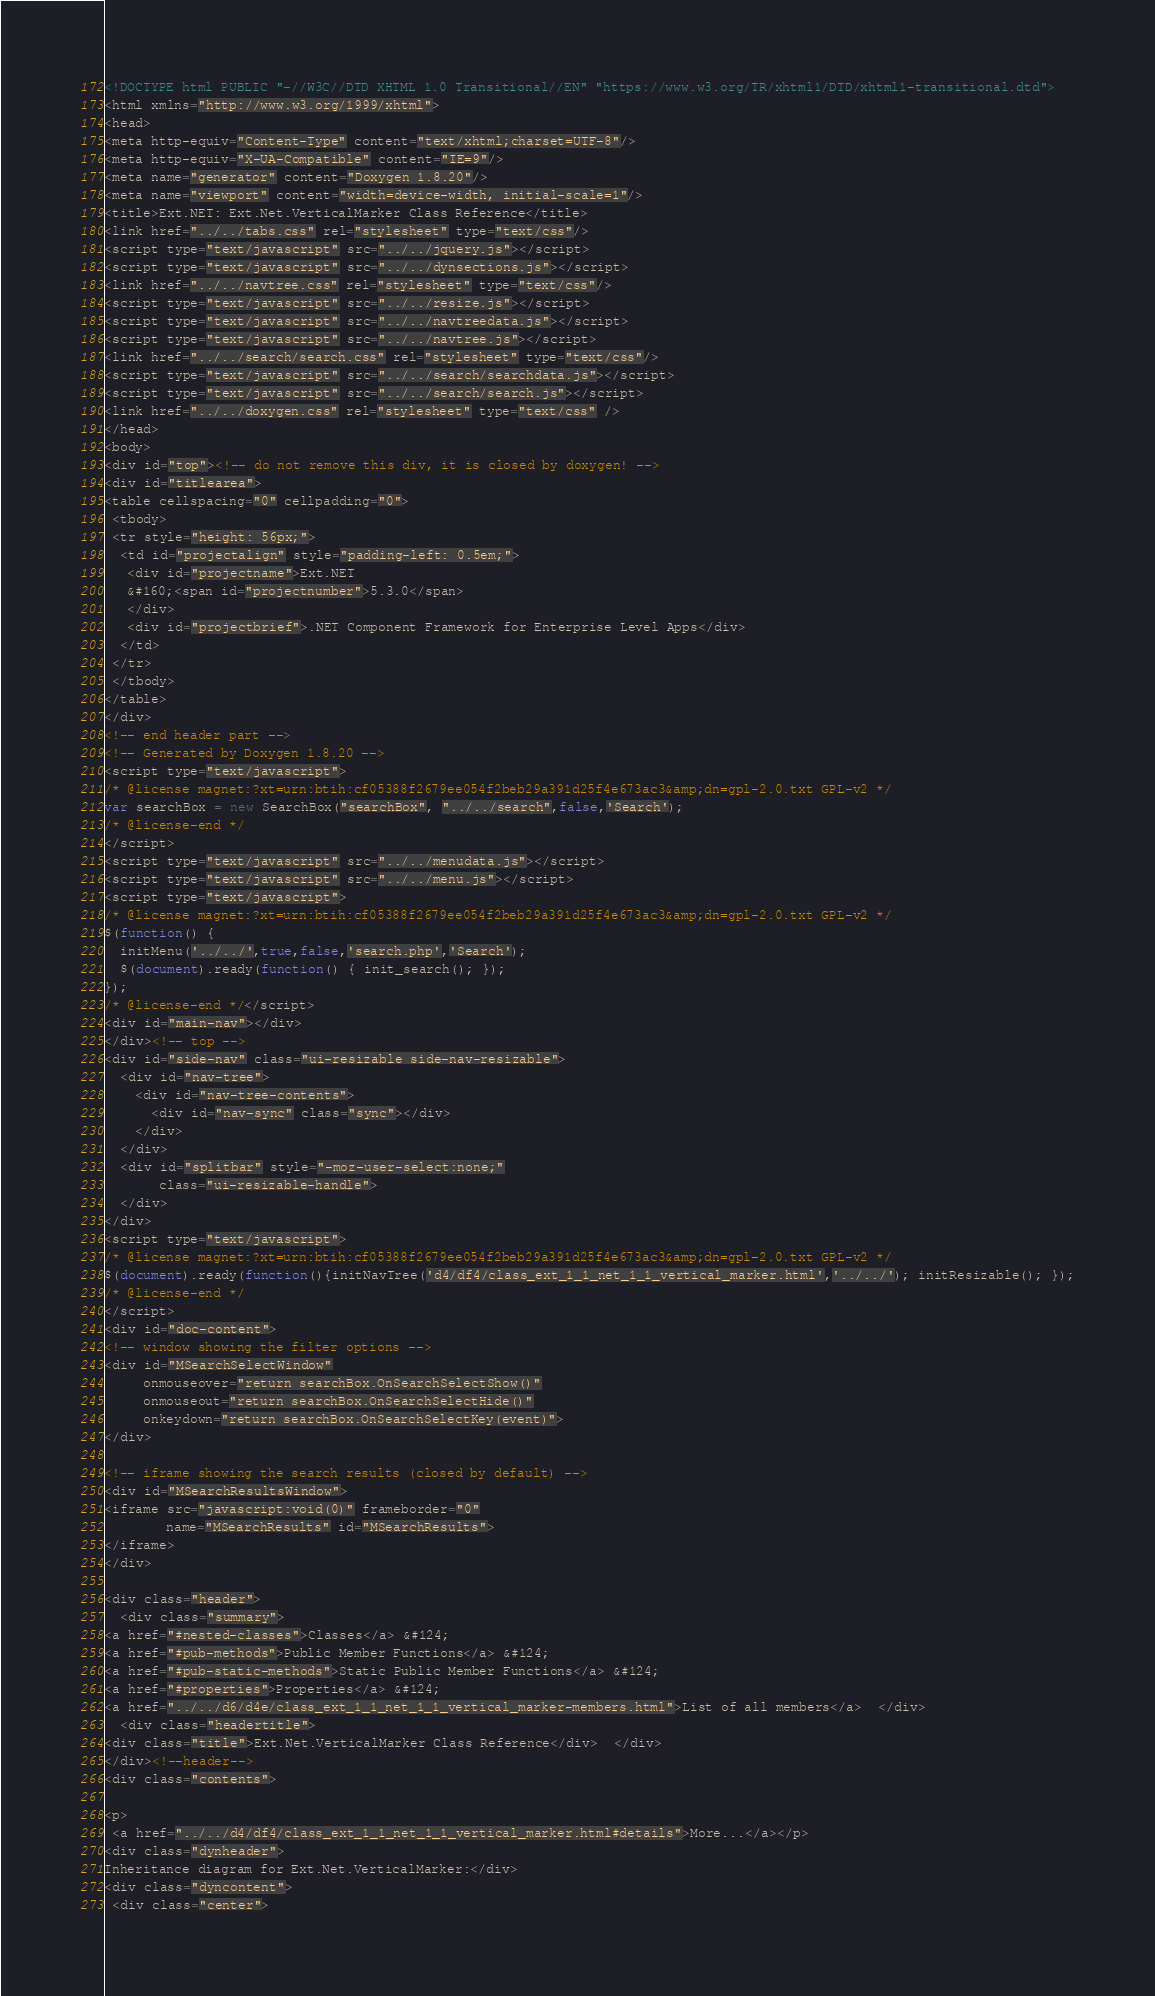<code> <loc_0><loc_0><loc_500><loc_500><_HTML_><!DOCTYPE html PUBLIC "-//W3C//DTD XHTML 1.0 Transitional//EN" "https://www.w3.org/TR/xhtml1/DTD/xhtml1-transitional.dtd">
<html xmlns="http://www.w3.org/1999/xhtml">
<head>
<meta http-equiv="Content-Type" content="text/xhtml;charset=UTF-8"/>
<meta http-equiv="X-UA-Compatible" content="IE=9"/>
<meta name="generator" content="Doxygen 1.8.20"/>
<meta name="viewport" content="width=device-width, initial-scale=1"/>
<title>Ext.NET: Ext.Net.VerticalMarker Class Reference</title>
<link href="../../tabs.css" rel="stylesheet" type="text/css"/>
<script type="text/javascript" src="../../jquery.js"></script>
<script type="text/javascript" src="../../dynsections.js"></script>
<link href="../../navtree.css" rel="stylesheet" type="text/css"/>
<script type="text/javascript" src="../../resize.js"></script>
<script type="text/javascript" src="../../navtreedata.js"></script>
<script type="text/javascript" src="../../navtree.js"></script>
<link href="../../search/search.css" rel="stylesheet" type="text/css"/>
<script type="text/javascript" src="../../search/searchdata.js"></script>
<script type="text/javascript" src="../../search/search.js"></script>
<link href="../../doxygen.css" rel="stylesheet" type="text/css" />
</head>
<body>
<div id="top"><!-- do not remove this div, it is closed by doxygen! -->
<div id="titlearea">
<table cellspacing="0" cellpadding="0">
 <tbody>
 <tr style="height: 56px;">
  <td id="projectalign" style="padding-left: 0.5em;">
   <div id="projectname">Ext.NET
   &#160;<span id="projectnumber">5.3.0</span>
   </div>
   <div id="projectbrief">.NET Component Framework for Enterprise Level Apps</div>
  </td>
 </tr>
 </tbody>
</table>
</div>
<!-- end header part -->
<!-- Generated by Doxygen 1.8.20 -->
<script type="text/javascript">
/* @license magnet:?xt=urn:btih:cf05388f2679ee054f2beb29a391d25f4e673ac3&amp;dn=gpl-2.0.txt GPL-v2 */
var searchBox = new SearchBox("searchBox", "../../search",false,'Search');
/* @license-end */
</script>
<script type="text/javascript" src="../../menudata.js"></script>
<script type="text/javascript" src="../../menu.js"></script>
<script type="text/javascript">
/* @license magnet:?xt=urn:btih:cf05388f2679ee054f2beb29a391d25f4e673ac3&amp;dn=gpl-2.0.txt GPL-v2 */
$(function() {
  initMenu('../../',true,false,'search.php','Search');
  $(document).ready(function() { init_search(); });
});
/* @license-end */</script>
<div id="main-nav"></div>
</div><!-- top -->
<div id="side-nav" class="ui-resizable side-nav-resizable">
  <div id="nav-tree">
    <div id="nav-tree-contents">
      <div id="nav-sync" class="sync"></div>
    </div>
  </div>
  <div id="splitbar" style="-moz-user-select:none;" 
       class="ui-resizable-handle">
  </div>
</div>
<script type="text/javascript">
/* @license magnet:?xt=urn:btih:cf05388f2679ee054f2beb29a391d25f4e673ac3&amp;dn=gpl-2.0.txt GPL-v2 */
$(document).ready(function(){initNavTree('d4/df4/class_ext_1_1_net_1_1_vertical_marker.html','../../'); initResizable(); });
/* @license-end */
</script>
<div id="doc-content">
<!-- window showing the filter options -->
<div id="MSearchSelectWindow"
     onmouseover="return searchBox.OnSearchSelectShow()"
     onmouseout="return searchBox.OnSearchSelectHide()"
     onkeydown="return searchBox.OnSearchSelectKey(event)">
</div>

<!-- iframe showing the search results (closed by default) -->
<div id="MSearchResultsWindow">
<iframe src="javascript:void(0)" frameborder="0" 
        name="MSearchResults" id="MSearchResults">
</iframe>
</div>

<div class="header">
  <div class="summary">
<a href="#nested-classes">Classes</a> &#124;
<a href="#pub-methods">Public Member Functions</a> &#124;
<a href="#pub-static-methods">Static Public Member Functions</a> &#124;
<a href="#properties">Properties</a> &#124;
<a href="../../d6/d4e/class_ext_1_1_net_1_1_vertical_marker-members.html">List of all members</a>  </div>
  <div class="headertitle">
<div class="title">Ext.Net.VerticalMarker Class Reference</div>  </div>
</div><!--header-->
<div class="contents">

<p> 
 <a href="../../d4/df4/class_ext_1_1_net_1_1_vertical_marker.html#details">More...</a></p>
<div class="dynheader">
Inheritance diagram for Ext.Net.VerticalMarker:</div>
<div class="dyncontent">
 <div class="center"></code> 